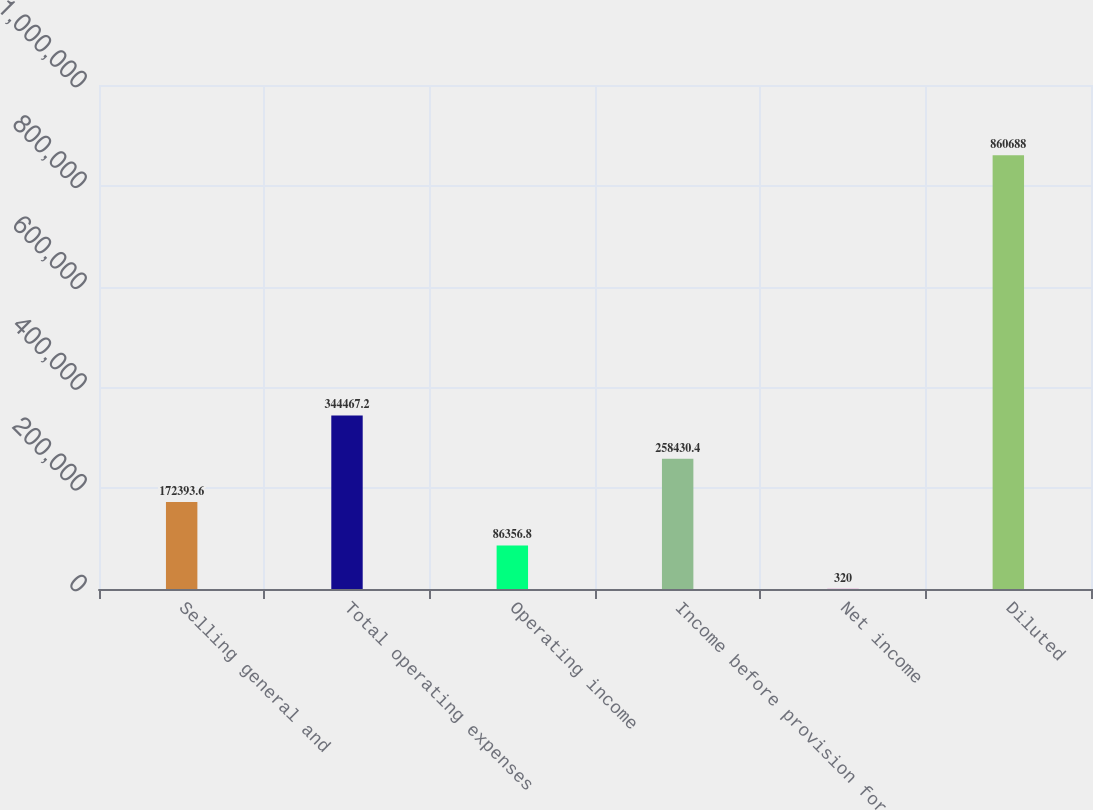Convert chart to OTSL. <chart><loc_0><loc_0><loc_500><loc_500><bar_chart><fcel>Selling general and<fcel>Total operating expenses<fcel>Operating income<fcel>Income before provision for<fcel>Net income<fcel>Diluted<nl><fcel>172394<fcel>344467<fcel>86356.8<fcel>258430<fcel>320<fcel>860688<nl></chart> 